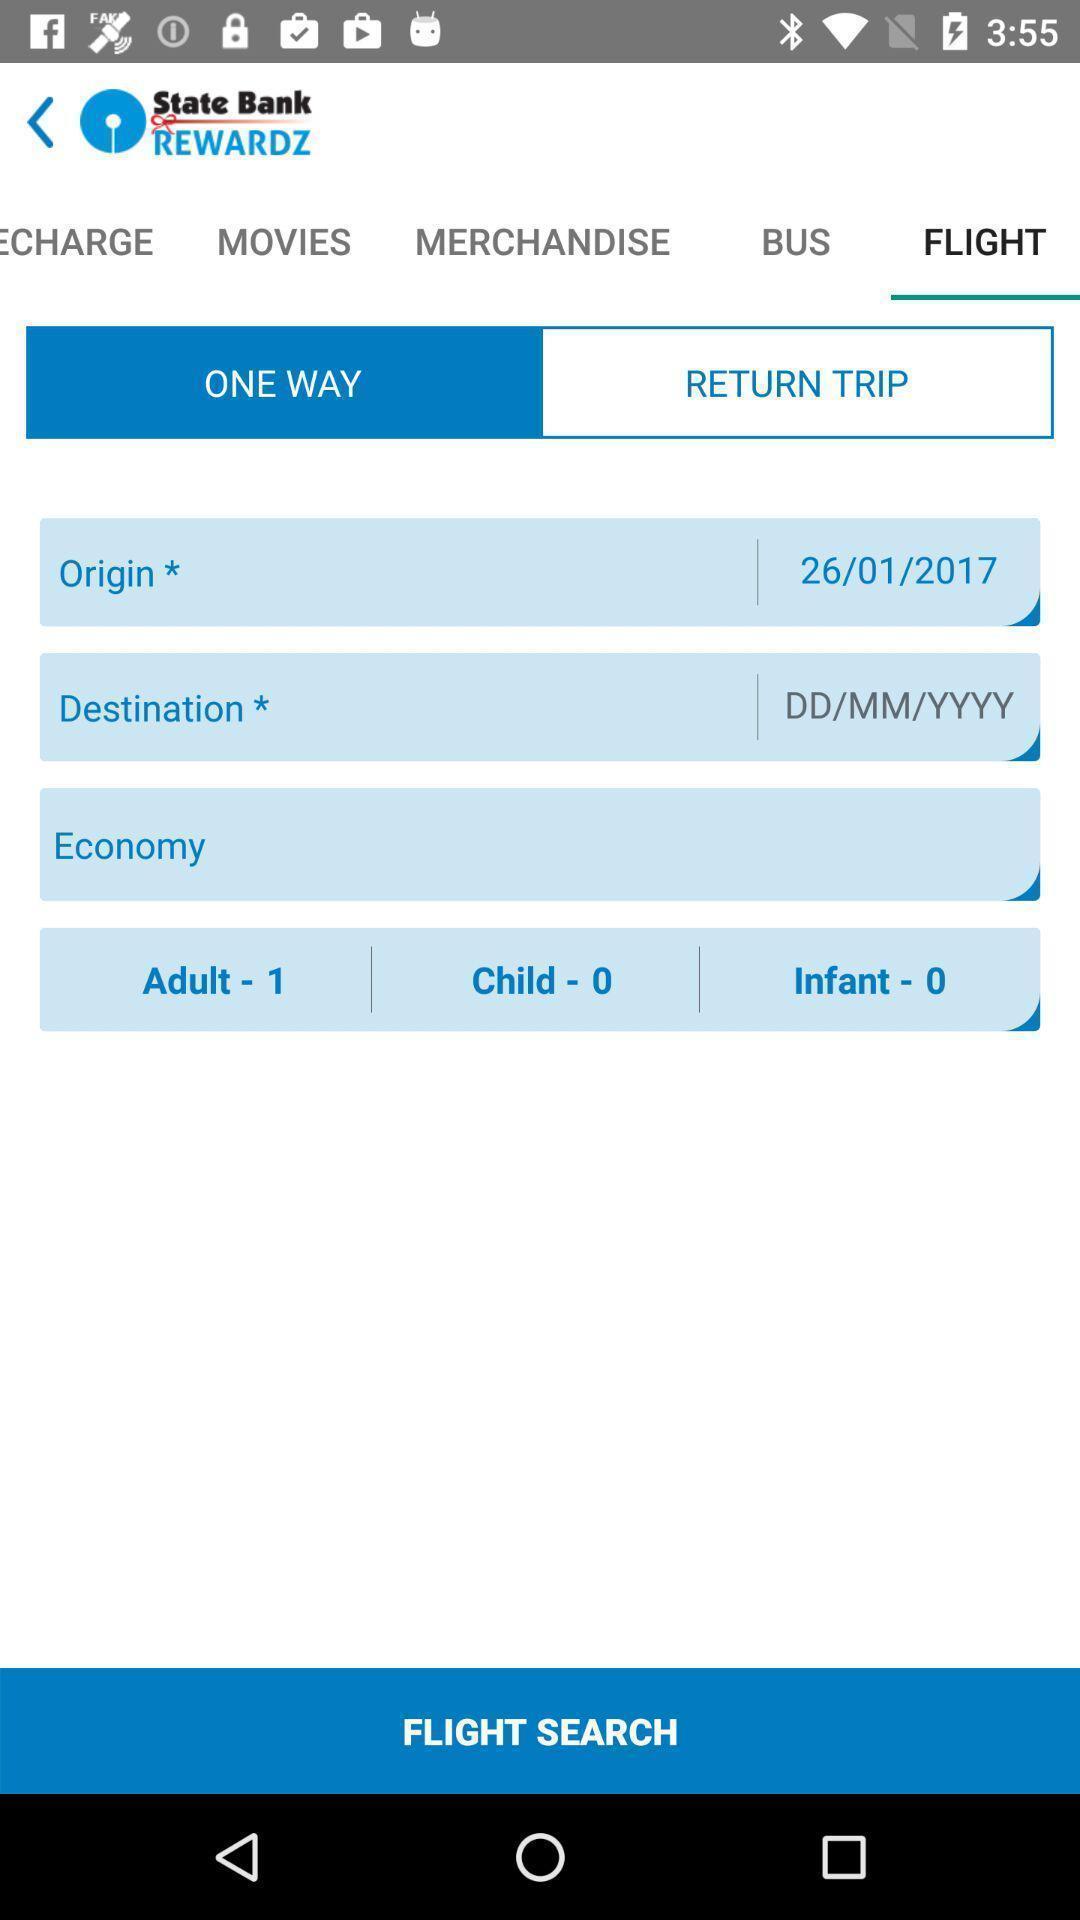Describe the visual elements of this screenshot. Window displaying booking of flights. 